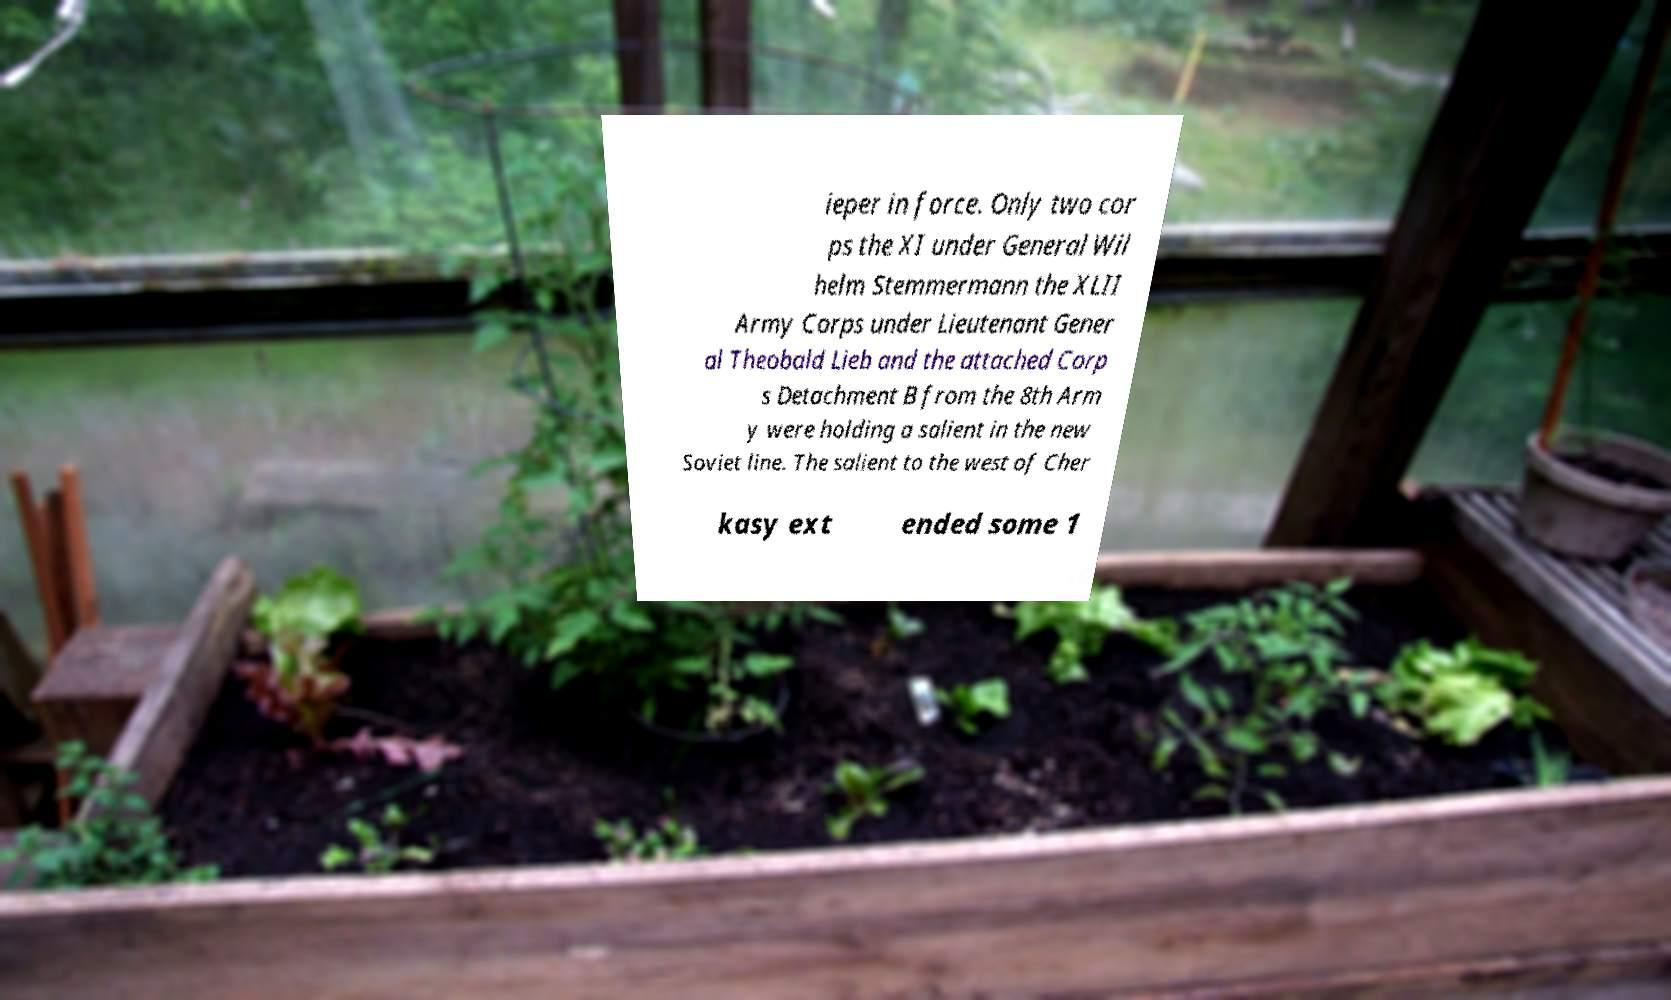Please read and relay the text visible in this image. What does it say? ieper in force. Only two cor ps the XI under General Wil helm Stemmermann the XLII Army Corps under Lieutenant Gener al Theobald Lieb and the attached Corp s Detachment B from the 8th Arm y were holding a salient in the new Soviet line. The salient to the west of Cher kasy ext ended some 1 